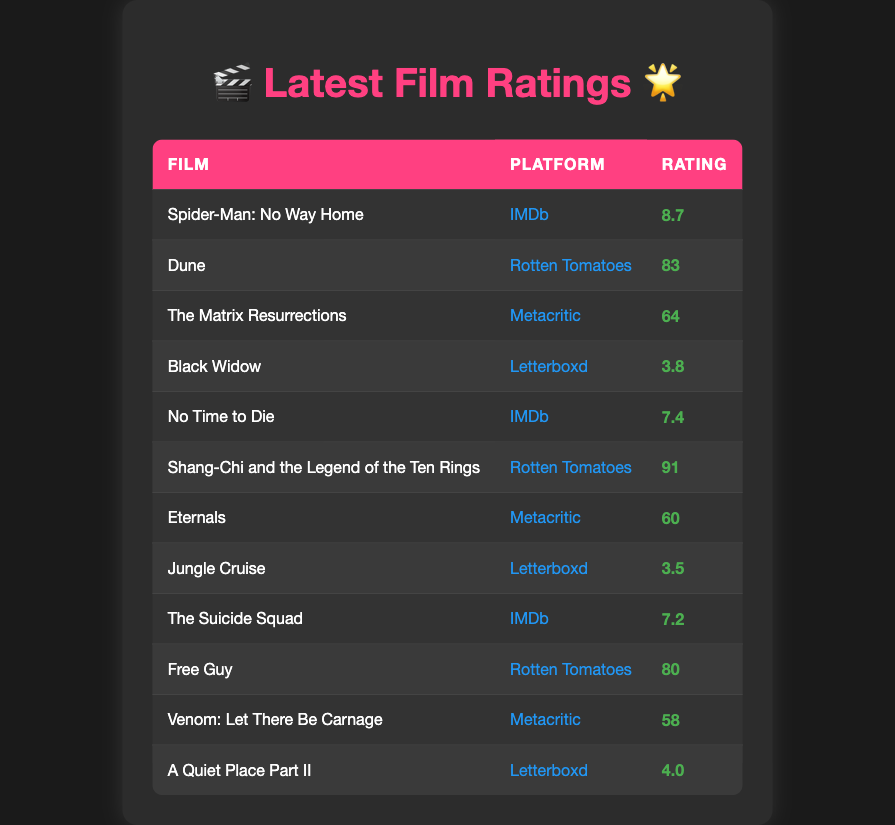What film received the highest rating on IMDb? The table shows the film "Spider-Man: No Way Home" with a rating of 8.7 on IMDb, which is the highest rating listed for that platform.
Answer: Spider-Man: No Way Home How many films are rated above 80 on Rotten Tomatoes? The table lists two films with ratings above 80 on Rotten Tomatoes: "Dune" (83) and "Shang-Chi and the Legend of the Ten Rings" (91). Counting these gives a total of 2 films.
Answer: 2 What is the average rating of films on Letterboxd? The films rated on Letterboxd are "Black Widow" (3.8), "Jungle Cruise" (3.5), and "A Quiet Place Part II" (4.0). Summing these ratings gives 3.8 + 3.5 + 4.0 = 11.3. Dividing by the number of films, which is 3, gives an average of 11.3 / 3 = 3.77.
Answer: 3.77 Did any film receive a rating of 91? The table shows "Shang-Chi and the Legend of the Ten Rings" with a rating of 91. Hence, this fact is true.
Answer: Yes Which platform has the lowest average rating among the listed films? For IMDb, the films have ratings of 8.7, 7.4, and 7.2, giving an average of (8.7 + 7.4 + 7.2) / 3 = 7.77. For Rotten Tomatoes, the ratings are 83 and 91, averaging (83 + 91) / 2 = 87. For Metacritic, the ratings are 64, 60, and 58, averaging (64 + 60 + 58) / 3 = 60.67. For Letterboxd, the ratings average to 3.77. Comparing these averages, Letterboxd has the lowest average rating.
Answer: Letterboxd 